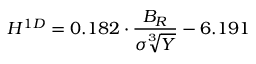Convert formula to latex. <formula><loc_0><loc_0><loc_500><loc_500>{ H ^ { 1 D } = 0 . 1 8 2 \cdot \frac { B _ { R } } { \sigma \sqrt { [ } 3 ] { Y } } - 6 . 1 9 1 }</formula> 